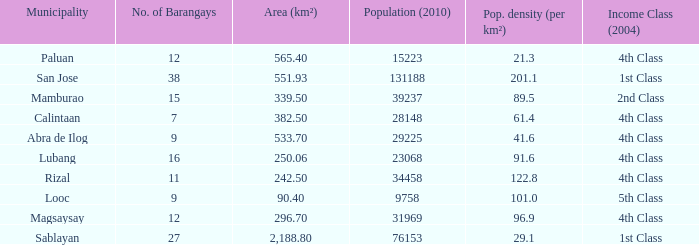What was the smallist population in 2010? 9758.0. 